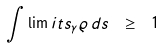<formula> <loc_0><loc_0><loc_500><loc_500>\int \lim i t s _ { \gamma } \varrho \, d s \ \geq \ 1</formula> 